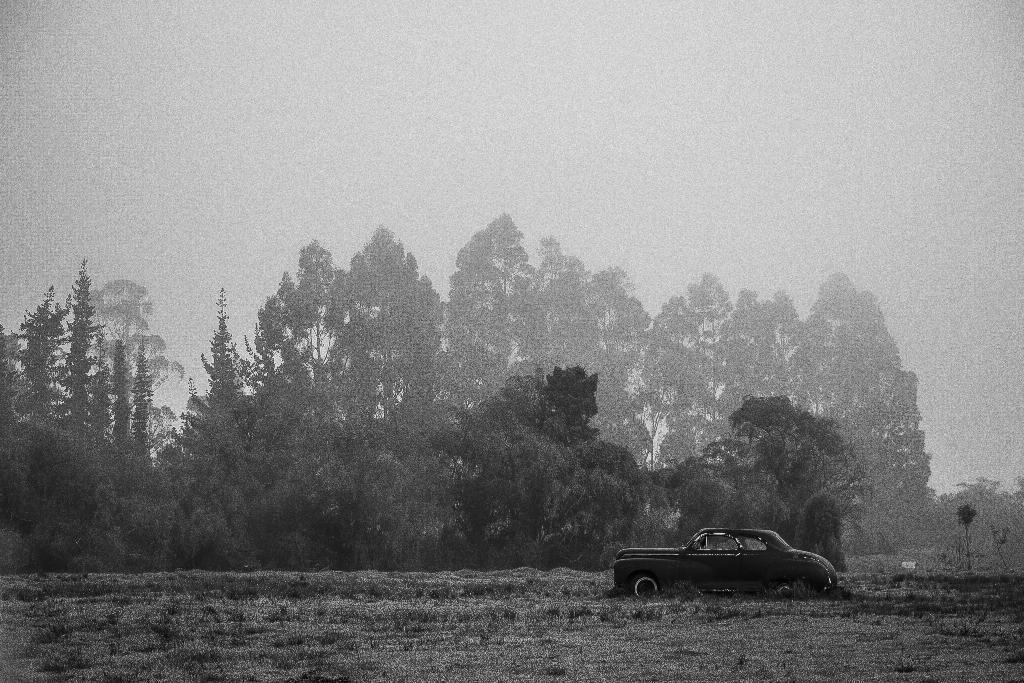Describe this image in one or two sentences. In this image we can see a car on a ground. In the background there are trees and sky. 